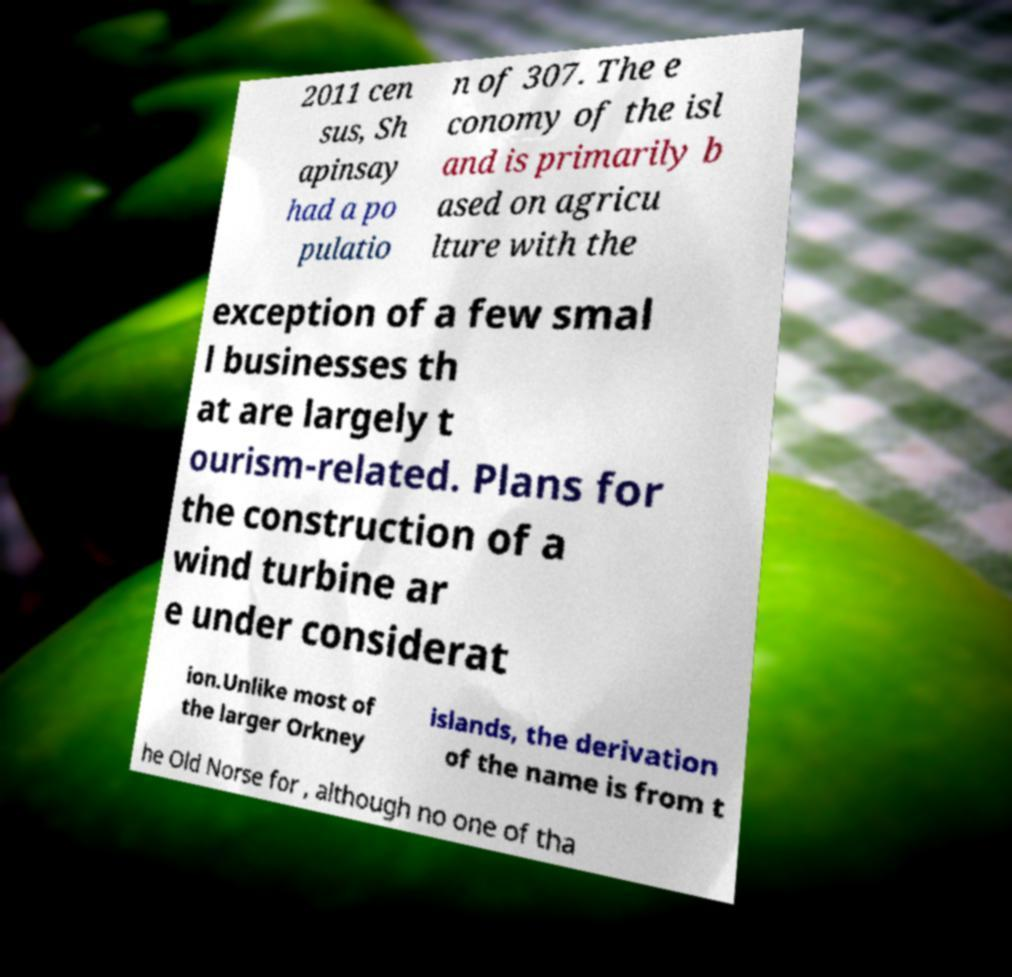Can you accurately transcribe the text from the provided image for me? 2011 cen sus, Sh apinsay had a po pulatio n of 307. The e conomy of the isl and is primarily b ased on agricu lture with the exception of a few smal l businesses th at are largely t ourism-related. Plans for the construction of a wind turbine ar e under considerat ion.Unlike most of the larger Orkney islands, the derivation of the name is from t he Old Norse for , although no one of tha 